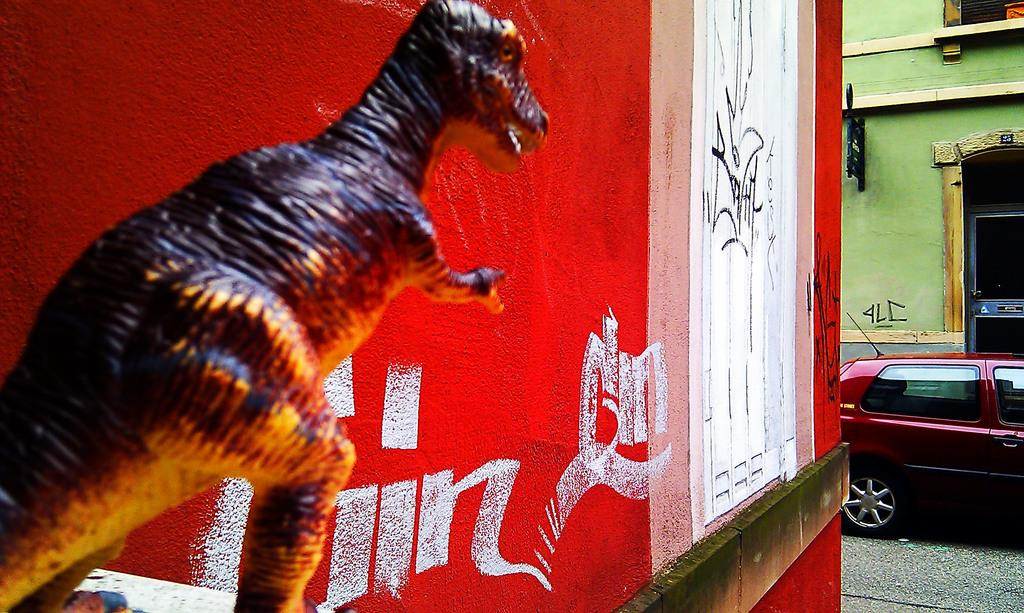What can be found on the left side of the image? There is a sculpture on the left side of the image. What is the color of the wall next to the sculpture? The wall next to the sculpture is red. What is located on the right side of the image? There is a building on the right side of the image. What mode of transportation can be seen in the image? There is a car on the road in the image. What type of reaction can be seen from the sculpture in the image? There is no reaction visible from the sculpture, as it is an inanimate object. What view can be seen from the building in the image? The provided facts do not mention a view from the building, so it cannot be determined from the image. 